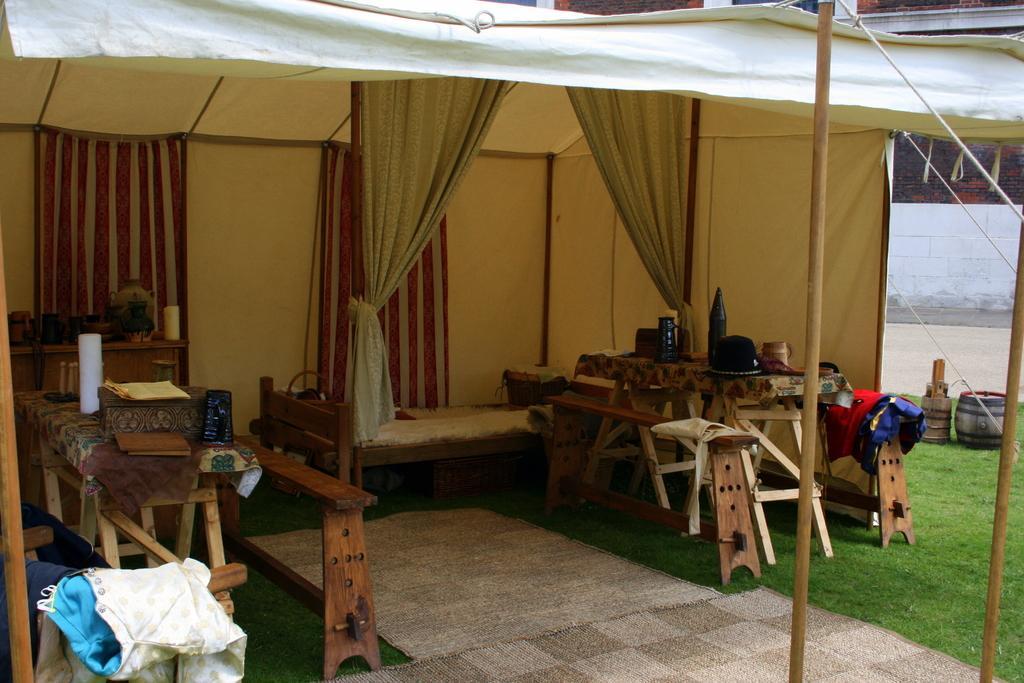Can you describe this image briefly? In this image we can see a tent. On the left side of the image there is a table, clothes and some objects. On the right side of the image we can see bottles, cap, benches and a bed. 